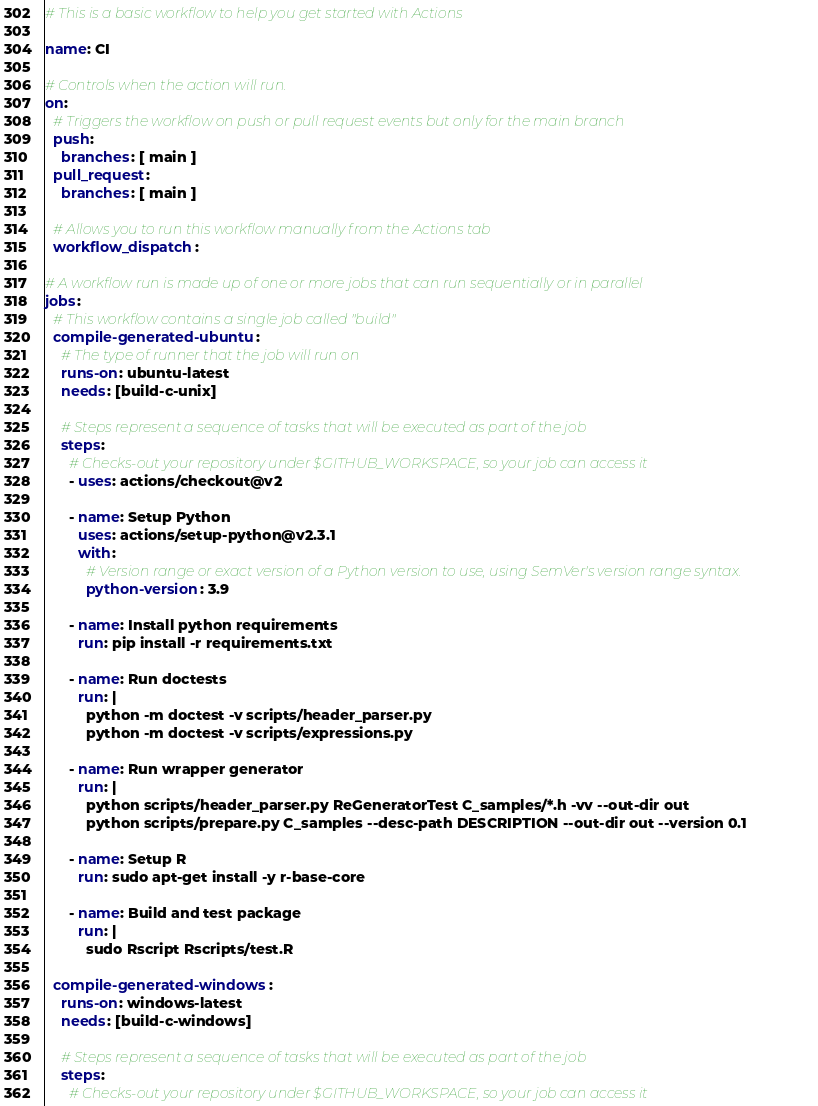<code> <loc_0><loc_0><loc_500><loc_500><_YAML_># This is a basic workflow to help you get started with Actions

name: CI

# Controls when the action will run. 
on:
  # Triggers the workflow on push or pull request events but only for the main branch
  push:
    branches: [ main ]
  pull_request:
    branches: [ main ]

  # Allows you to run this workflow manually from the Actions tab
  workflow_dispatch:

# A workflow run is made up of one or more jobs that can run sequentially or in parallel
jobs:
  # This workflow contains a single job called "build"
  compile-generated-ubuntu:
    # The type of runner that the job will run on
    runs-on: ubuntu-latest
    needs: [build-c-unix]

    # Steps represent a sequence of tasks that will be executed as part of the job
    steps:
      # Checks-out your repository under $GITHUB_WORKSPACE, so your job can access it
      - uses: actions/checkout@v2

      - name: Setup Python
        uses: actions/setup-python@v2.3.1
        with:
          # Version range or exact version of a Python version to use, using SemVer's version range syntax.
          python-version: 3.9

      - name: Install python requirements
        run: pip install -r requirements.txt

      - name: Run doctests
        run: |
          python -m doctest -v scripts/header_parser.py
          python -m doctest -v scripts/expressions.py

      - name: Run wrapper generator
        run: |
          python scripts/header_parser.py ReGeneratorTest C_samples/*.h -vv --out-dir out
          python scripts/prepare.py C_samples --desc-path DESCRIPTION --out-dir out --version 0.1
     
      - name: Setup R
        run: sudo apt-get install -y r-base-core

      - name: Build and test package
        run: |
          sudo Rscript Rscripts/test.R
         
  compile-generated-windows:
    runs-on: windows-latest
    needs: [build-c-windows]
    
    # Steps represent a sequence of tasks that will be executed as part of the job
    steps:
      # Checks-out your repository under $GITHUB_WORKSPACE, so your job can access it</code> 